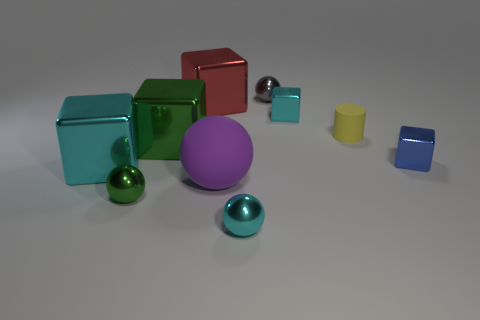Subtract all big red blocks. How many blocks are left? 4 Subtract all brown blocks. Subtract all green spheres. How many blocks are left? 5 Subtract all spheres. How many objects are left? 6 Add 6 purple balls. How many purple balls are left? 7 Add 5 cubes. How many cubes exist? 10 Subtract 0 purple cylinders. How many objects are left? 10 Subtract all small cylinders. Subtract all big yellow matte cylinders. How many objects are left? 9 